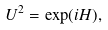<formula> <loc_0><loc_0><loc_500><loc_500>U ^ { 2 } = \exp ( i H ) ,</formula> 